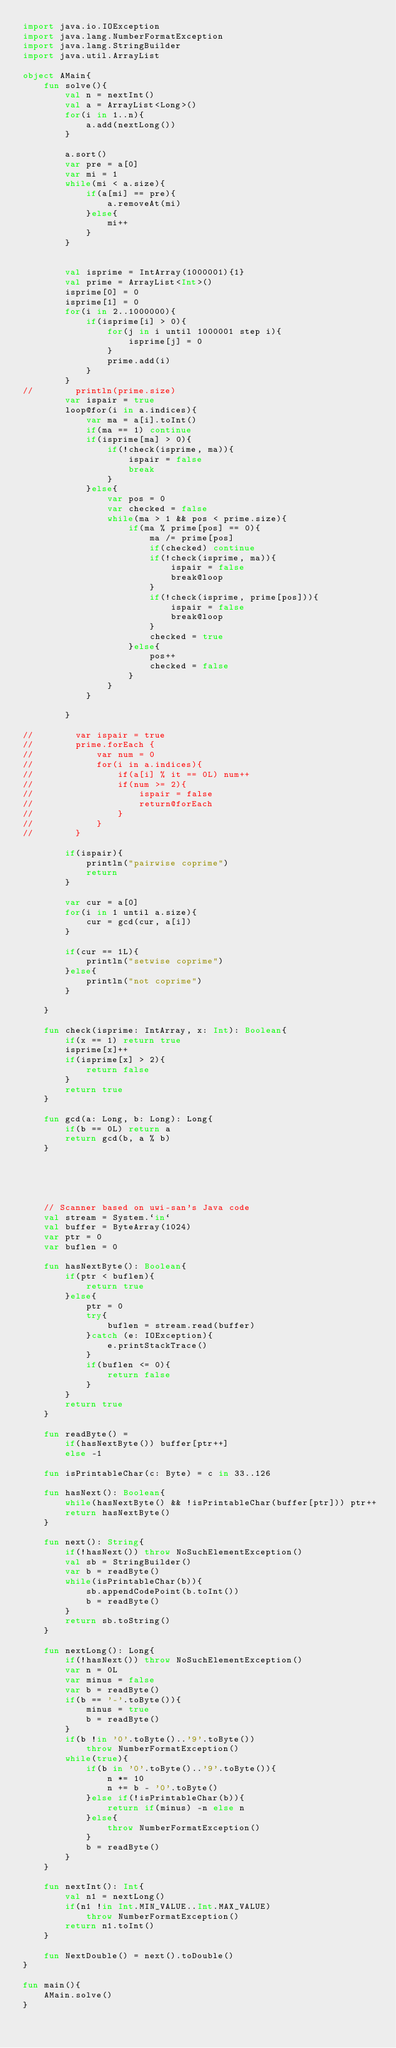<code> <loc_0><loc_0><loc_500><loc_500><_Kotlin_>import java.io.IOException
import java.lang.NumberFormatException
import java.lang.StringBuilder
import java.util.ArrayList

object AMain{
    fun solve(){
        val n = nextInt()
        val a = ArrayList<Long>()
        for(i in 1..n){
            a.add(nextLong())
        }

        a.sort()
        var pre = a[0]
        var mi = 1
        while(mi < a.size){
            if(a[mi] == pre){
                a.removeAt(mi)
            }else{
                mi++
            }
        }


        val isprime = IntArray(1000001){1}
        val prime = ArrayList<Int>()
        isprime[0] = 0
        isprime[1] = 0
        for(i in 2..1000000){
            if(isprime[i] > 0){
                for(j in i until 1000001 step i){
                    isprime[j] = 0
                }
                prime.add(i)
            }
        }
//        println(prime.size)
        var ispair = true
        loop@for(i in a.indices){
            var ma = a[i].toInt()
            if(ma == 1) continue
            if(isprime[ma] > 0){
                if(!check(isprime, ma)){
                    ispair = false
                    break
                }
            }else{
                var pos = 0
                var checked = false
                while(ma > 1 && pos < prime.size){
                    if(ma % prime[pos] == 0){
                        ma /= prime[pos]
                        if(checked) continue
                        if(!check(isprime, ma)){
                            ispair = false
                            break@loop
                        }
                        if(!check(isprime, prime[pos])){
                            ispair = false
                            break@loop
                        }
                        checked = true
                    }else{
                        pos++
                        checked = false
                    }
                }
            }

        }

//        var ispair = true
//        prime.forEach {
//            var num = 0
//            for(i in a.indices){
//                if(a[i] % it == 0L) num++
//                if(num >= 2){
//                    ispair = false
//                    return@forEach
//                }
//            }
//        }

        if(ispair){
            println("pairwise coprime")
            return
        }

        var cur = a[0]
        for(i in 1 until a.size){
            cur = gcd(cur, a[i])
        }

        if(cur == 1L){
            println("setwise coprime")
        }else{
            println("not coprime")
        }

    }

    fun check(isprime: IntArray, x: Int): Boolean{
        if(x == 1) return true
        isprime[x]++
        if(isprime[x] > 2){
            return false
        }
        return true
    }

    fun gcd(a: Long, b: Long): Long{
        if(b == 0L) return a
        return gcd(b, a % b)
    }





    // Scanner based on uwi-san's Java code
    val stream = System.`in`
    val buffer = ByteArray(1024)
    var ptr = 0
    var buflen = 0

    fun hasNextByte(): Boolean{
        if(ptr < buflen){
            return true
        }else{
            ptr = 0
            try{
                buflen = stream.read(buffer)
            }catch (e: IOException){
                e.printStackTrace()
            }
            if(buflen <= 0){
                return false
            }
        }
        return true
    }

    fun readByte() =
        if(hasNextByte()) buffer[ptr++]
        else -1

    fun isPrintableChar(c: Byte) = c in 33..126

    fun hasNext(): Boolean{
        while(hasNextByte() && !isPrintableChar(buffer[ptr])) ptr++
        return hasNextByte()
    }

    fun next(): String{
        if(!hasNext()) throw NoSuchElementException()
        val sb = StringBuilder()
        var b = readByte()
        while(isPrintableChar(b)){
            sb.appendCodePoint(b.toInt())
            b = readByte()
        }
        return sb.toString()
    }

    fun nextLong(): Long{
        if(!hasNext()) throw NoSuchElementException()
        var n = 0L
        var minus = false
        var b = readByte()
        if(b == '-'.toByte()){
            minus = true
            b = readByte()
        }
        if(b !in '0'.toByte()..'9'.toByte())
            throw NumberFormatException()
        while(true){
            if(b in '0'.toByte()..'9'.toByte()){
                n *= 10
                n += b - '0'.toByte()
            }else if(!isPrintableChar(b)){
                return if(minus) -n else n
            }else{
                throw NumberFormatException()
            }
            b = readByte()
        }
    }

    fun nextInt(): Int{
        val n1 = nextLong()
        if(n1 !in Int.MIN_VALUE..Int.MAX_VALUE)
            throw NumberFormatException()
        return n1.toInt()
    }

    fun NextDouble() = next().toDouble()
}

fun main(){
    AMain.solve()
}

</code> 